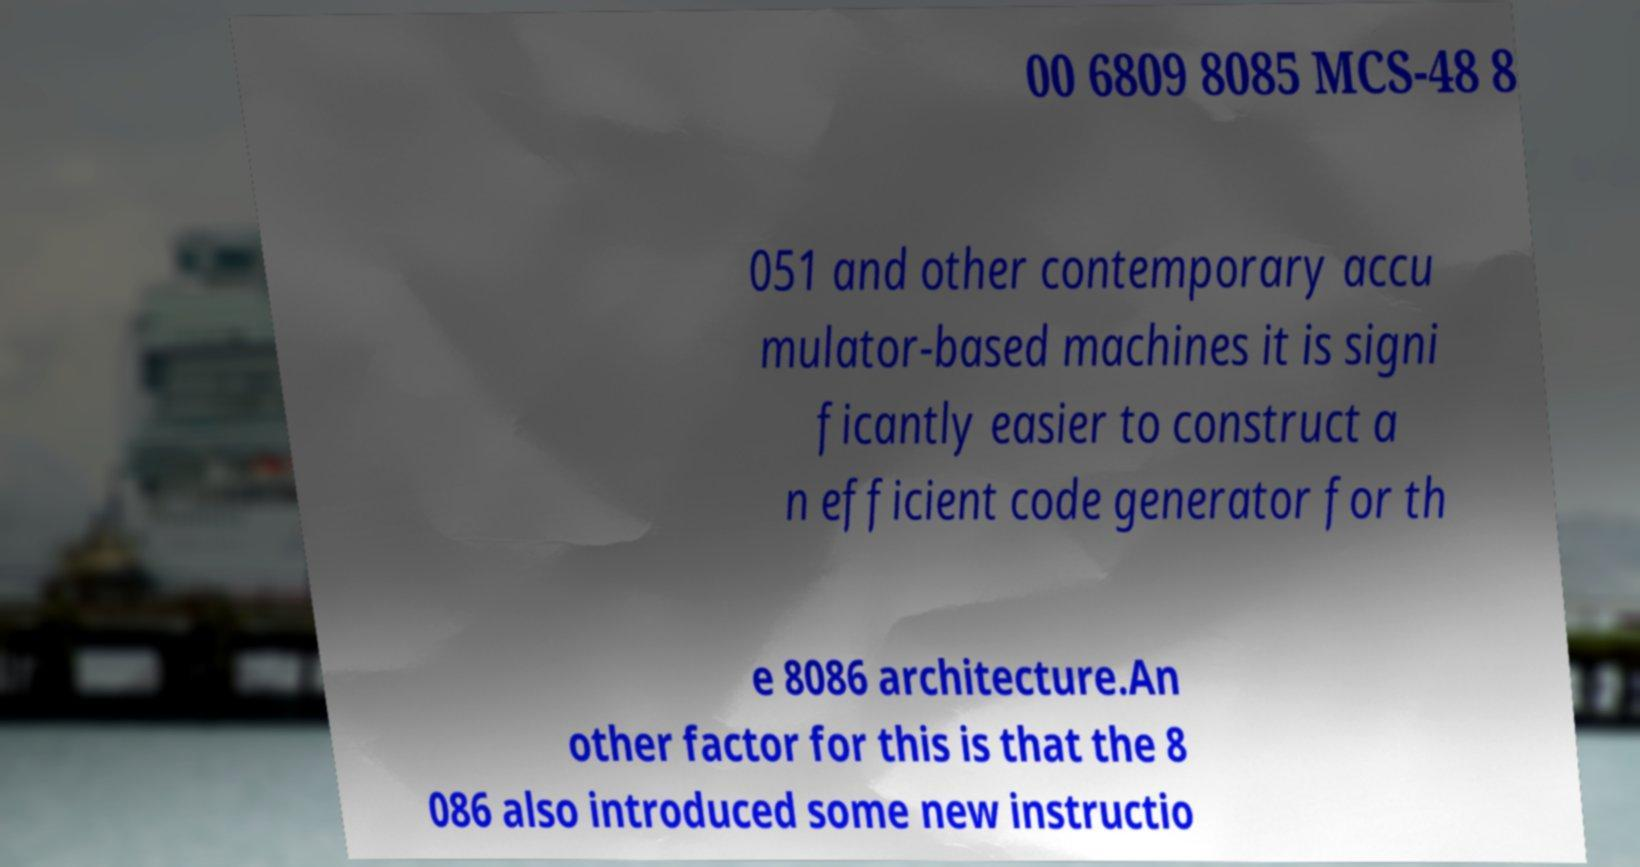There's text embedded in this image that I need extracted. Can you transcribe it verbatim? 00 6809 8085 MCS-48 8 051 and other contemporary accu mulator-based machines it is signi ficantly easier to construct a n efficient code generator for th e 8086 architecture.An other factor for this is that the 8 086 also introduced some new instructio 